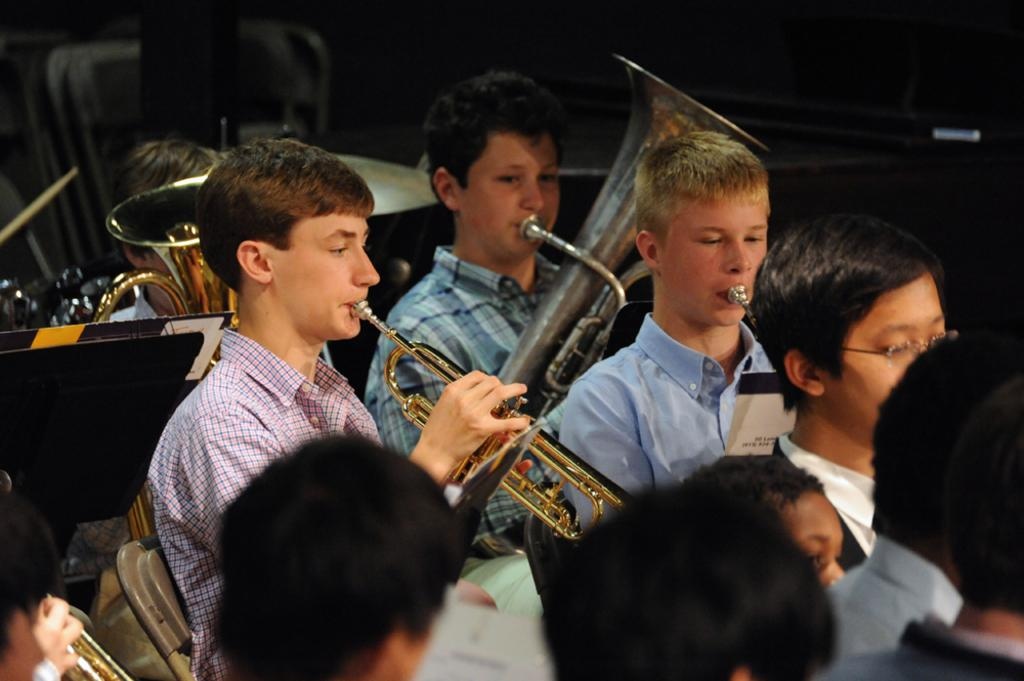What are the people in the image doing? The people in the image are playing musical instruments. What else can be seen in the image besides the people playing instruments? There are books on a stand in the image. What type of coat is being worn by the volcano in the image? There is no volcano present in the image, and therefore no coat can be associated with it. 